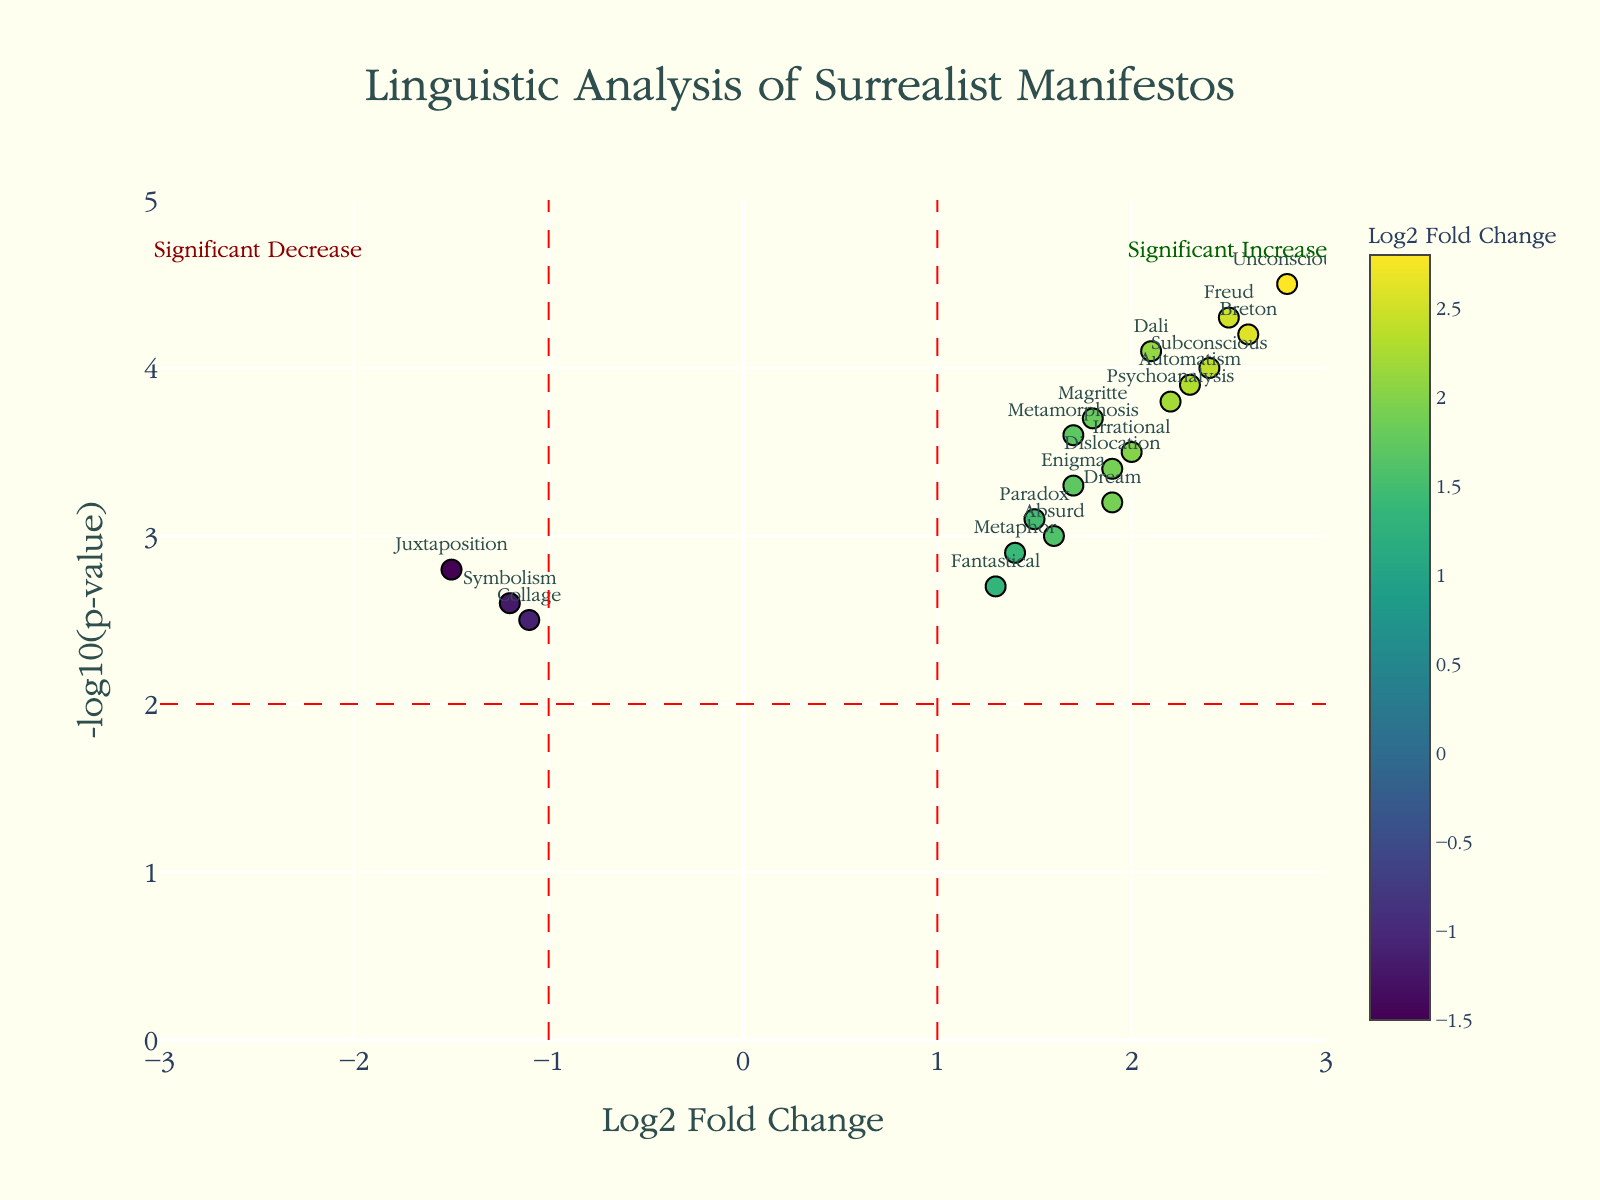What is the title of the plot? The title is clearly stated at the top center of the figure. It reads 'Linguistic Analysis of Surrealist Manifestos'.
Answer: Linguistic Analysis of Surrealist Manifestos What axis represents the Log2 Fold Change? The x-axis is labeled as 'Log2 Fold Change', and it measures the fold change of the word frequency in a log scale to base 2.
Answer: x-axis Which word shows the highest semantic importance? The word with the highest 'NegativeLogPValue' on the y-axis represents the highest semantic importance. The word 'Unconscious' is at the maximum y-value of 4.5.
Answer: Unconscious What does the red vertical line at x = 1 represent? The red vertical lines at x = 1 and x = -1 denote the threshold for significant increase and decrease in word frequency. The line at x = 1 indicates a significant increase limit.
Answer: Significant increase limit Are there any words with a negative log2 fold change and a significant increase in importance? Words with negative log2 fold change are to the left of the vertical line at x = 0, while those with high semantic importance are above the horizontal line at y = 2. The word 'Juxtaposition' (-1.5, 2.8) fits this criteria.
Answer: Yes, Juxtaposition Which words have both high fold change and high semantic importance? Words with high log2 fold change and high negative log p-value are located in the top right corner of the plot. These words include 'Unconscious', 'Freud', 'Breton', and 'Subconscious'.
Answer: Unconscious, Freud, Breton, Subconscious How many words have a log2 fold change greater than 2? To count these words, look at the data points to the right of the vertical red line at x = 2. The words 'Unconscious', 'Freud', 'Breton', and 'Subconscious' meet this criterion, totaling four.
Answer: 4 What can be concluded about the word 'Symbolism' in terms of fold change and importance? 'Symbolism' has a log2 fold change of -1.2 and a negative log p-value of 2.6. This locates it to the left of x = -1 and above y = 2, indicating a significant decrease in fold change but still viewed as important from a statistical standpoint.
Answer: Significant decrease in fold change, high importance Compare 'Absurd' and 'Paradox' in terms of their semantic importance and fold change. 'Absurd' has a log2 fold change of 1.6 and a negative log p-value of 3.0, while 'Paradox' has a log2 fold change of 1.5 and a negative log p-value of 3.1. Both words are similar, but 'Paradox' has a slightly higher importance (y-value).
Answer: Paradox has slightly higher importance Which words indicate the influence of key surrealists like Dalí and Breton? Looking at higher fold changes and higher importance, 'Dali' and 'Breton' both fit these criteria. 'Dali' has values (2.1, 4.1) and 'Breton' has (2.6, 4.2).
Answer: Dali and Breton 